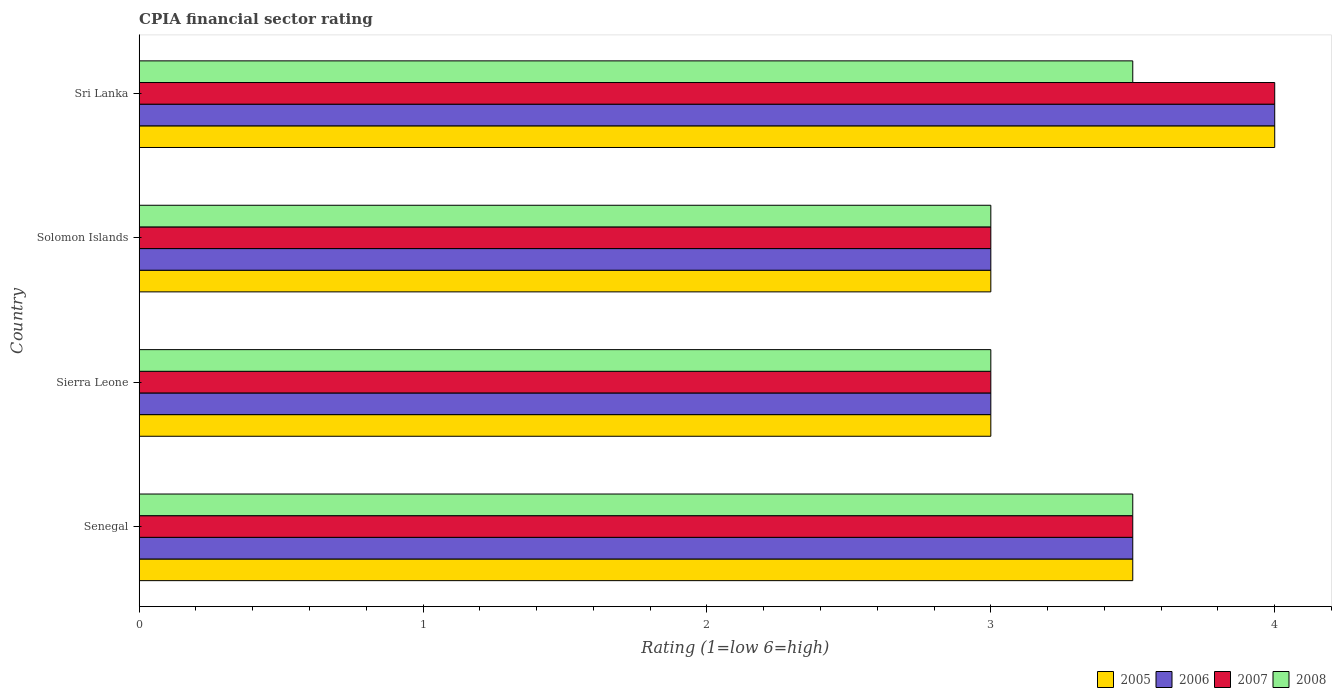How many different coloured bars are there?
Give a very brief answer. 4. Are the number of bars per tick equal to the number of legend labels?
Offer a very short reply. Yes. How many bars are there on the 2nd tick from the top?
Provide a succinct answer. 4. What is the label of the 1st group of bars from the top?
Keep it short and to the point. Sri Lanka. In how many cases, is the number of bars for a given country not equal to the number of legend labels?
Your response must be concise. 0. What is the CPIA rating in 2006 in Senegal?
Keep it short and to the point. 3.5. In which country was the CPIA rating in 2008 maximum?
Offer a terse response. Senegal. In which country was the CPIA rating in 2008 minimum?
Give a very brief answer. Sierra Leone. What is the total CPIA rating in 2005 in the graph?
Offer a terse response. 13.5. What is the average CPIA rating in 2006 per country?
Offer a very short reply. 3.38. What is the ratio of the CPIA rating in 2006 in Senegal to that in Solomon Islands?
Your answer should be very brief. 1.17. Is the difference between the CPIA rating in 2008 in Solomon Islands and Sri Lanka greater than the difference between the CPIA rating in 2005 in Solomon Islands and Sri Lanka?
Keep it short and to the point. Yes. What is the difference between the highest and the second highest CPIA rating in 2008?
Provide a succinct answer. 0. What does the 3rd bar from the bottom in Solomon Islands represents?
Your answer should be very brief. 2007. Are all the bars in the graph horizontal?
Give a very brief answer. Yes. What is the difference between two consecutive major ticks on the X-axis?
Ensure brevity in your answer.  1. Where does the legend appear in the graph?
Offer a very short reply. Bottom right. How many legend labels are there?
Offer a terse response. 4. What is the title of the graph?
Offer a very short reply. CPIA financial sector rating. Does "1970" appear as one of the legend labels in the graph?
Offer a terse response. No. What is the label or title of the X-axis?
Provide a succinct answer. Rating (1=low 6=high). What is the label or title of the Y-axis?
Offer a very short reply. Country. What is the Rating (1=low 6=high) in 2005 in Senegal?
Offer a very short reply. 3.5. What is the Rating (1=low 6=high) of 2006 in Sierra Leone?
Your answer should be compact. 3. What is the Rating (1=low 6=high) in 2006 in Solomon Islands?
Your response must be concise. 3. What is the Rating (1=low 6=high) in 2007 in Solomon Islands?
Ensure brevity in your answer.  3. What is the Rating (1=low 6=high) of 2006 in Sri Lanka?
Offer a terse response. 4. What is the Rating (1=low 6=high) of 2007 in Sri Lanka?
Keep it short and to the point. 4. Across all countries, what is the maximum Rating (1=low 6=high) of 2006?
Ensure brevity in your answer.  4. Across all countries, what is the maximum Rating (1=low 6=high) of 2007?
Offer a very short reply. 4. Across all countries, what is the minimum Rating (1=low 6=high) of 2005?
Offer a terse response. 3. Across all countries, what is the minimum Rating (1=low 6=high) of 2006?
Provide a short and direct response. 3. What is the total Rating (1=low 6=high) in 2007 in the graph?
Your answer should be very brief. 13.5. What is the difference between the Rating (1=low 6=high) in 2005 in Senegal and that in Sierra Leone?
Give a very brief answer. 0.5. What is the difference between the Rating (1=low 6=high) of 2006 in Senegal and that in Sierra Leone?
Give a very brief answer. 0.5. What is the difference between the Rating (1=low 6=high) of 2007 in Senegal and that in Sierra Leone?
Your response must be concise. 0.5. What is the difference between the Rating (1=low 6=high) of 2008 in Senegal and that in Sierra Leone?
Provide a short and direct response. 0.5. What is the difference between the Rating (1=low 6=high) of 2005 in Senegal and that in Solomon Islands?
Provide a succinct answer. 0.5. What is the difference between the Rating (1=low 6=high) in 2007 in Senegal and that in Sri Lanka?
Your answer should be very brief. -0.5. What is the difference between the Rating (1=low 6=high) in 2008 in Sierra Leone and that in Solomon Islands?
Your answer should be compact. 0. What is the difference between the Rating (1=low 6=high) in 2007 in Sierra Leone and that in Sri Lanka?
Keep it short and to the point. -1. What is the difference between the Rating (1=low 6=high) of 2008 in Sierra Leone and that in Sri Lanka?
Offer a terse response. -0.5. What is the difference between the Rating (1=low 6=high) in 2005 in Solomon Islands and that in Sri Lanka?
Give a very brief answer. -1. What is the difference between the Rating (1=low 6=high) of 2007 in Solomon Islands and that in Sri Lanka?
Your answer should be very brief. -1. What is the difference between the Rating (1=low 6=high) in 2008 in Solomon Islands and that in Sri Lanka?
Your answer should be very brief. -0.5. What is the difference between the Rating (1=low 6=high) of 2005 in Senegal and the Rating (1=low 6=high) of 2006 in Sierra Leone?
Ensure brevity in your answer.  0.5. What is the difference between the Rating (1=low 6=high) of 2005 in Senegal and the Rating (1=low 6=high) of 2007 in Sierra Leone?
Your answer should be very brief. 0.5. What is the difference between the Rating (1=low 6=high) of 2005 in Senegal and the Rating (1=low 6=high) of 2008 in Sierra Leone?
Offer a very short reply. 0.5. What is the difference between the Rating (1=low 6=high) in 2006 in Senegal and the Rating (1=low 6=high) in 2007 in Sierra Leone?
Provide a succinct answer. 0.5. What is the difference between the Rating (1=low 6=high) of 2006 in Senegal and the Rating (1=low 6=high) of 2008 in Sierra Leone?
Provide a succinct answer. 0.5. What is the difference between the Rating (1=low 6=high) in 2007 in Senegal and the Rating (1=low 6=high) in 2008 in Sierra Leone?
Give a very brief answer. 0.5. What is the difference between the Rating (1=low 6=high) in 2005 in Senegal and the Rating (1=low 6=high) in 2006 in Solomon Islands?
Offer a very short reply. 0.5. What is the difference between the Rating (1=low 6=high) in 2005 in Senegal and the Rating (1=low 6=high) in 2007 in Solomon Islands?
Keep it short and to the point. 0.5. What is the difference between the Rating (1=low 6=high) in 2005 in Senegal and the Rating (1=low 6=high) in 2008 in Solomon Islands?
Keep it short and to the point. 0.5. What is the difference between the Rating (1=low 6=high) in 2005 in Senegal and the Rating (1=low 6=high) in 2007 in Sri Lanka?
Your answer should be compact. -0.5. What is the difference between the Rating (1=low 6=high) in 2005 in Senegal and the Rating (1=low 6=high) in 2008 in Sri Lanka?
Provide a succinct answer. 0. What is the difference between the Rating (1=low 6=high) of 2006 in Senegal and the Rating (1=low 6=high) of 2007 in Sri Lanka?
Make the answer very short. -0.5. What is the difference between the Rating (1=low 6=high) in 2006 in Senegal and the Rating (1=low 6=high) in 2008 in Sri Lanka?
Ensure brevity in your answer.  0. What is the difference between the Rating (1=low 6=high) of 2007 in Sierra Leone and the Rating (1=low 6=high) of 2008 in Solomon Islands?
Your answer should be very brief. 0. What is the difference between the Rating (1=low 6=high) in 2005 in Sierra Leone and the Rating (1=low 6=high) in 2006 in Sri Lanka?
Your answer should be compact. -1. What is the difference between the Rating (1=low 6=high) in 2005 in Sierra Leone and the Rating (1=low 6=high) in 2007 in Sri Lanka?
Offer a very short reply. -1. What is the difference between the Rating (1=low 6=high) of 2006 in Sierra Leone and the Rating (1=low 6=high) of 2008 in Sri Lanka?
Provide a succinct answer. -0.5. What is the difference between the Rating (1=low 6=high) of 2007 in Sierra Leone and the Rating (1=low 6=high) of 2008 in Sri Lanka?
Your answer should be compact. -0.5. What is the difference between the Rating (1=low 6=high) in 2005 in Solomon Islands and the Rating (1=low 6=high) in 2006 in Sri Lanka?
Provide a succinct answer. -1. What is the difference between the Rating (1=low 6=high) of 2005 in Solomon Islands and the Rating (1=low 6=high) of 2007 in Sri Lanka?
Offer a very short reply. -1. What is the difference between the Rating (1=low 6=high) in 2005 in Solomon Islands and the Rating (1=low 6=high) in 2008 in Sri Lanka?
Provide a short and direct response. -0.5. What is the difference between the Rating (1=low 6=high) in 2006 in Solomon Islands and the Rating (1=low 6=high) in 2008 in Sri Lanka?
Your answer should be very brief. -0.5. What is the difference between the Rating (1=low 6=high) in 2007 in Solomon Islands and the Rating (1=low 6=high) in 2008 in Sri Lanka?
Your answer should be compact. -0.5. What is the average Rating (1=low 6=high) in 2005 per country?
Ensure brevity in your answer.  3.38. What is the average Rating (1=low 6=high) in 2006 per country?
Ensure brevity in your answer.  3.38. What is the average Rating (1=low 6=high) in 2007 per country?
Provide a succinct answer. 3.38. What is the average Rating (1=low 6=high) in 2008 per country?
Your answer should be very brief. 3.25. What is the difference between the Rating (1=low 6=high) of 2006 and Rating (1=low 6=high) of 2007 in Senegal?
Your response must be concise. 0. What is the difference between the Rating (1=low 6=high) in 2007 and Rating (1=low 6=high) in 2008 in Senegal?
Provide a succinct answer. 0. What is the difference between the Rating (1=low 6=high) of 2005 and Rating (1=low 6=high) of 2006 in Sierra Leone?
Provide a succinct answer. 0. What is the difference between the Rating (1=low 6=high) of 2006 and Rating (1=low 6=high) of 2007 in Sierra Leone?
Your response must be concise. 0. What is the difference between the Rating (1=low 6=high) in 2006 and Rating (1=low 6=high) in 2008 in Solomon Islands?
Your answer should be compact. 0. What is the difference between the Rating (1=low 6=high) in 2007 and Rating (1=low 6=high) in 2008 in Solomon Islands?
Offer a terse response. 0. What is the difference between the Rating (1=low 6=high) of 2005 and Rating (1=low 6=high) of 2007 in Sri Lanka?
Your response must be concise. 0. What is the difference between the Rating (1=low 6=high) of 2007 and Rating (1=low 6=high) of 2008 in Sri Lanka?
Offer a terse response. 0.5. What is the ratio of the Rating (1=low 6=high) in 2005 in Senegal to that in Sierra Leone?
Keep it short and to the point. 1.17. What is the ratio of the Rating (1=low 6=high) in 2007 in Senegal to that in Sierra Leone?
Keep it short and to the point. 1.17. What is the ratio of the Rating (1=low 6=high) in 2008 in Senegal to that in Sierra Leone?
Your answer should be very brief. 1.17. What is the ratio of the Rating (1=low 6=high) in 2005 in Senegal to that in Solomon Islands?
Offer a terse response. 1.17. What is the ratio of the Rating (1=low 6=high) of 2006 in Senegal to that in Solomon Islands?
Keep it short and to the point. 1.17. What is the ratio of the Rating (1=low 6=high) in 2005 in Senegal to that in Sri Lanka?
Provide a succinct answer. 0.88. What is the ratio of the Rating (1=low 6=high) in 2007 in Senegal to that in Sri Lanka?
Offer a very short reply. 0.88. What is the ratio of the Rating (1=low 6=high) in 2008 in Senegal to that in Sri Lanka?
Ensure brevity in your answer.  1. What is the ratio of the Rating (1=low 6=high) of 2005 in Sierra Leone to that in Solomon Islands?
Your answer should be very brief. 1. What is the ratio of the Rating (1=low 6=high) of 2006 in Sierra Leone to that in Solomon Islands?
Ensure brevity in your answer.  1. What is the ratio of the Rating (1=low 6=high) of 2007 in Sierra Leone to that in Sri Lanka?
Your answer should be compact. 0.75. What is the ratio of the Rating (1=low 6=high) of 2006 in Solomon Islands to that in Sri Lanka?
Keep it short and to the point. 0.75. What is the difference between the highest and the second highest Rating (1=low 6=high) of 2007?
Ensure brevity in your answer.  0.5. What is the difference between the highest and the lowest Rating (1=low 6=high) of 2007?
Give a very brief answer. 1. 